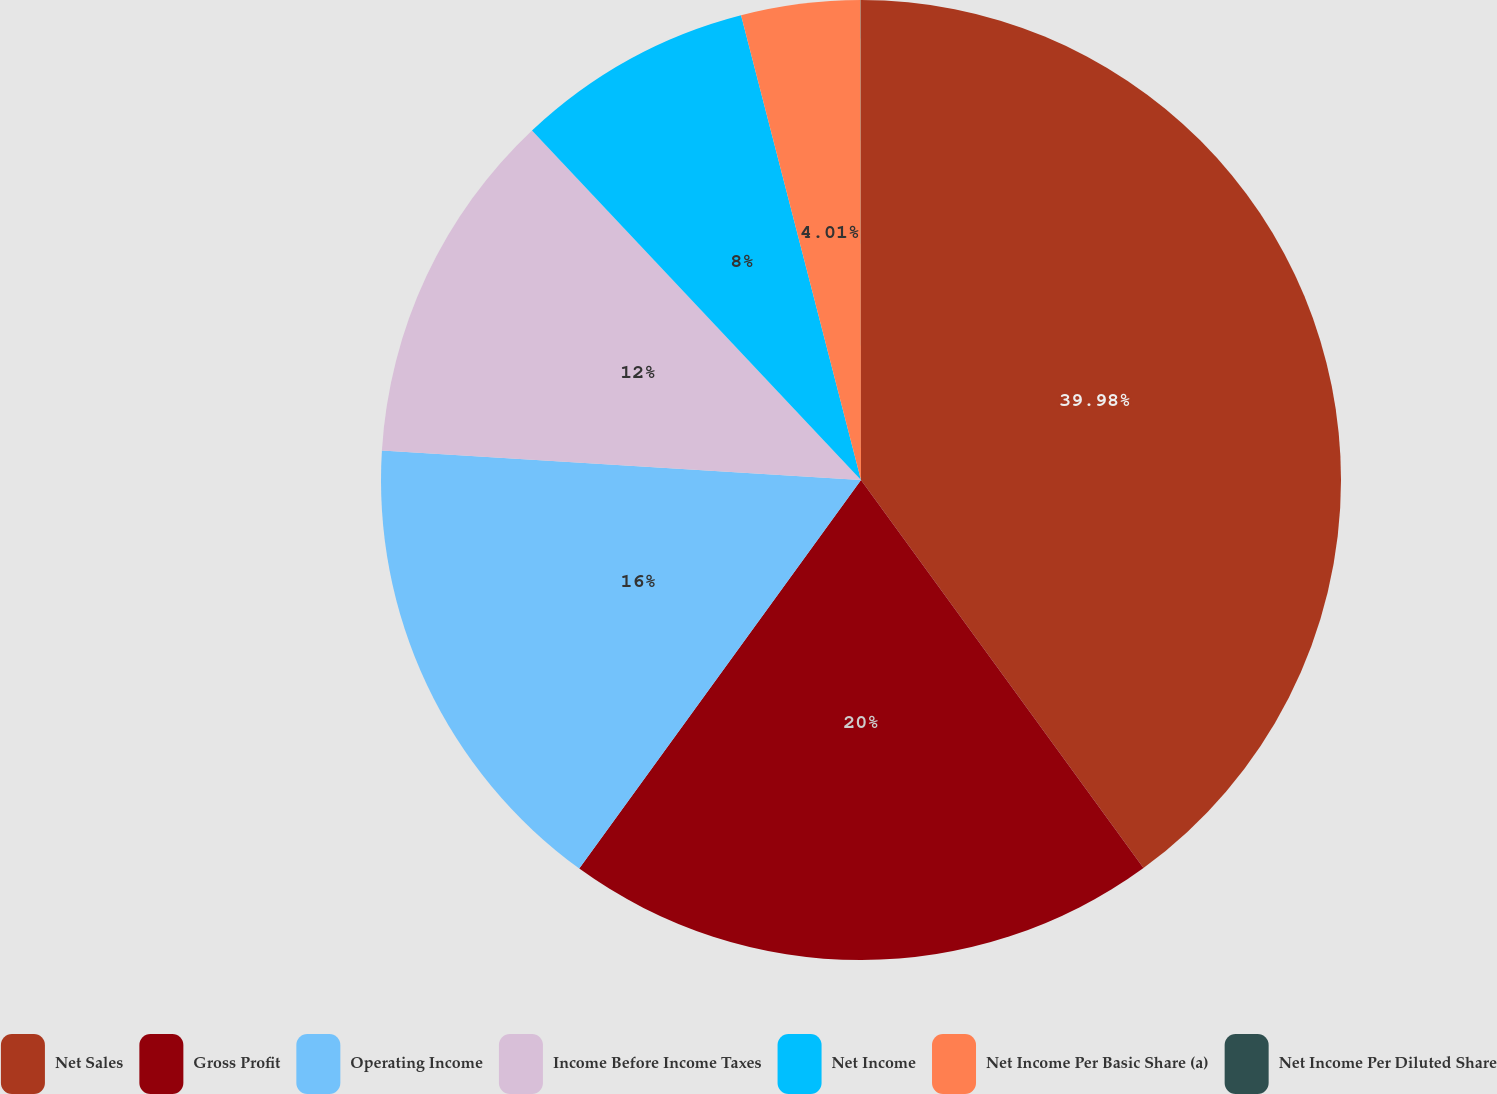Convert chart. <chart><loc_0><loc_0><loc_500><loc_500><pie_chart><fcel>Net Sales<fcel>Gross Profit<fcel>Operating Income<fcel>Income Before Income Taxes<fcel>Net Income<fcel>Net Income Per Basic Share (a)<fcel>Net Income Per Diluted Share<nl><fcel>39.99%<fcel>20.0%<fcel>16.0%<fcel>12.0%<fcel>8.0%<fcel>4.01%<fcel>0.01%<nl></chart> 